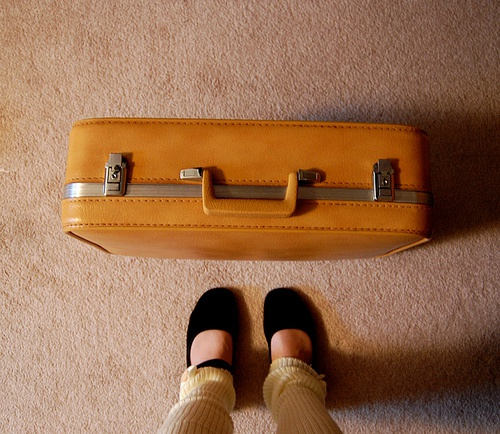Describe the objects in this image and their specific colors. I can see suitcase in tan, red, orange, and maroon tones and people in tan, black, maroon, and brown tones in this image. 